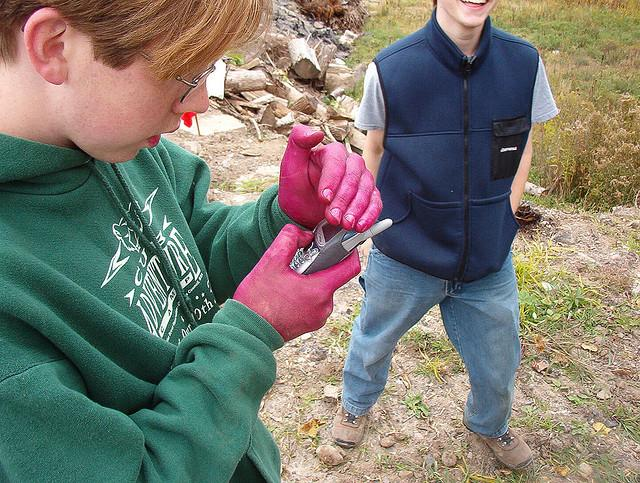Why is the boy blocking the view of his phone?

Choices:
A) visibility
B) safety
C) in anger
D) as joke visibility 